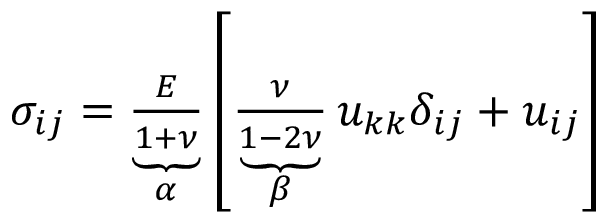Convert formula to latex. <formula><loc_0><loc_0><loc_500><loc_500>\begin{array} { r } { \sigma _ { i j } = \underbrace { \frac { E } { 1 + \nu } } _ { \alpha } \left [ \underbrace { \frac { \nu } { 1 - 2 \nu } } _ { \beta } u _ { k k } \delta _ { i j } + u _ { i j } \right ] } \end{array}</formula> 